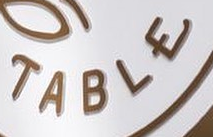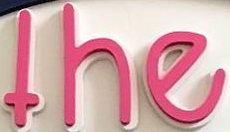What words are shown in these images in order, separated by a semicolon? TABLE; the 